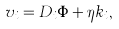<formula> <loc_0><loc_0><loc_500><loc_500>v _ { i } = D _ { i } \Phi + \eta k _ { i } ,</formula> 